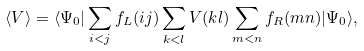<formula> <loc_0><loc_0><loc_500><loc_500>\langle V \rangle = \langle \Psi _ { 0 } | \sum _ { i < j } f _ { L } ( i j ) \sum _ { k < l } V ( k l ) \sum _ { m < n } f _ { R } ( m n ) | \Psi _ { 0 } \rangle ,</formula> 